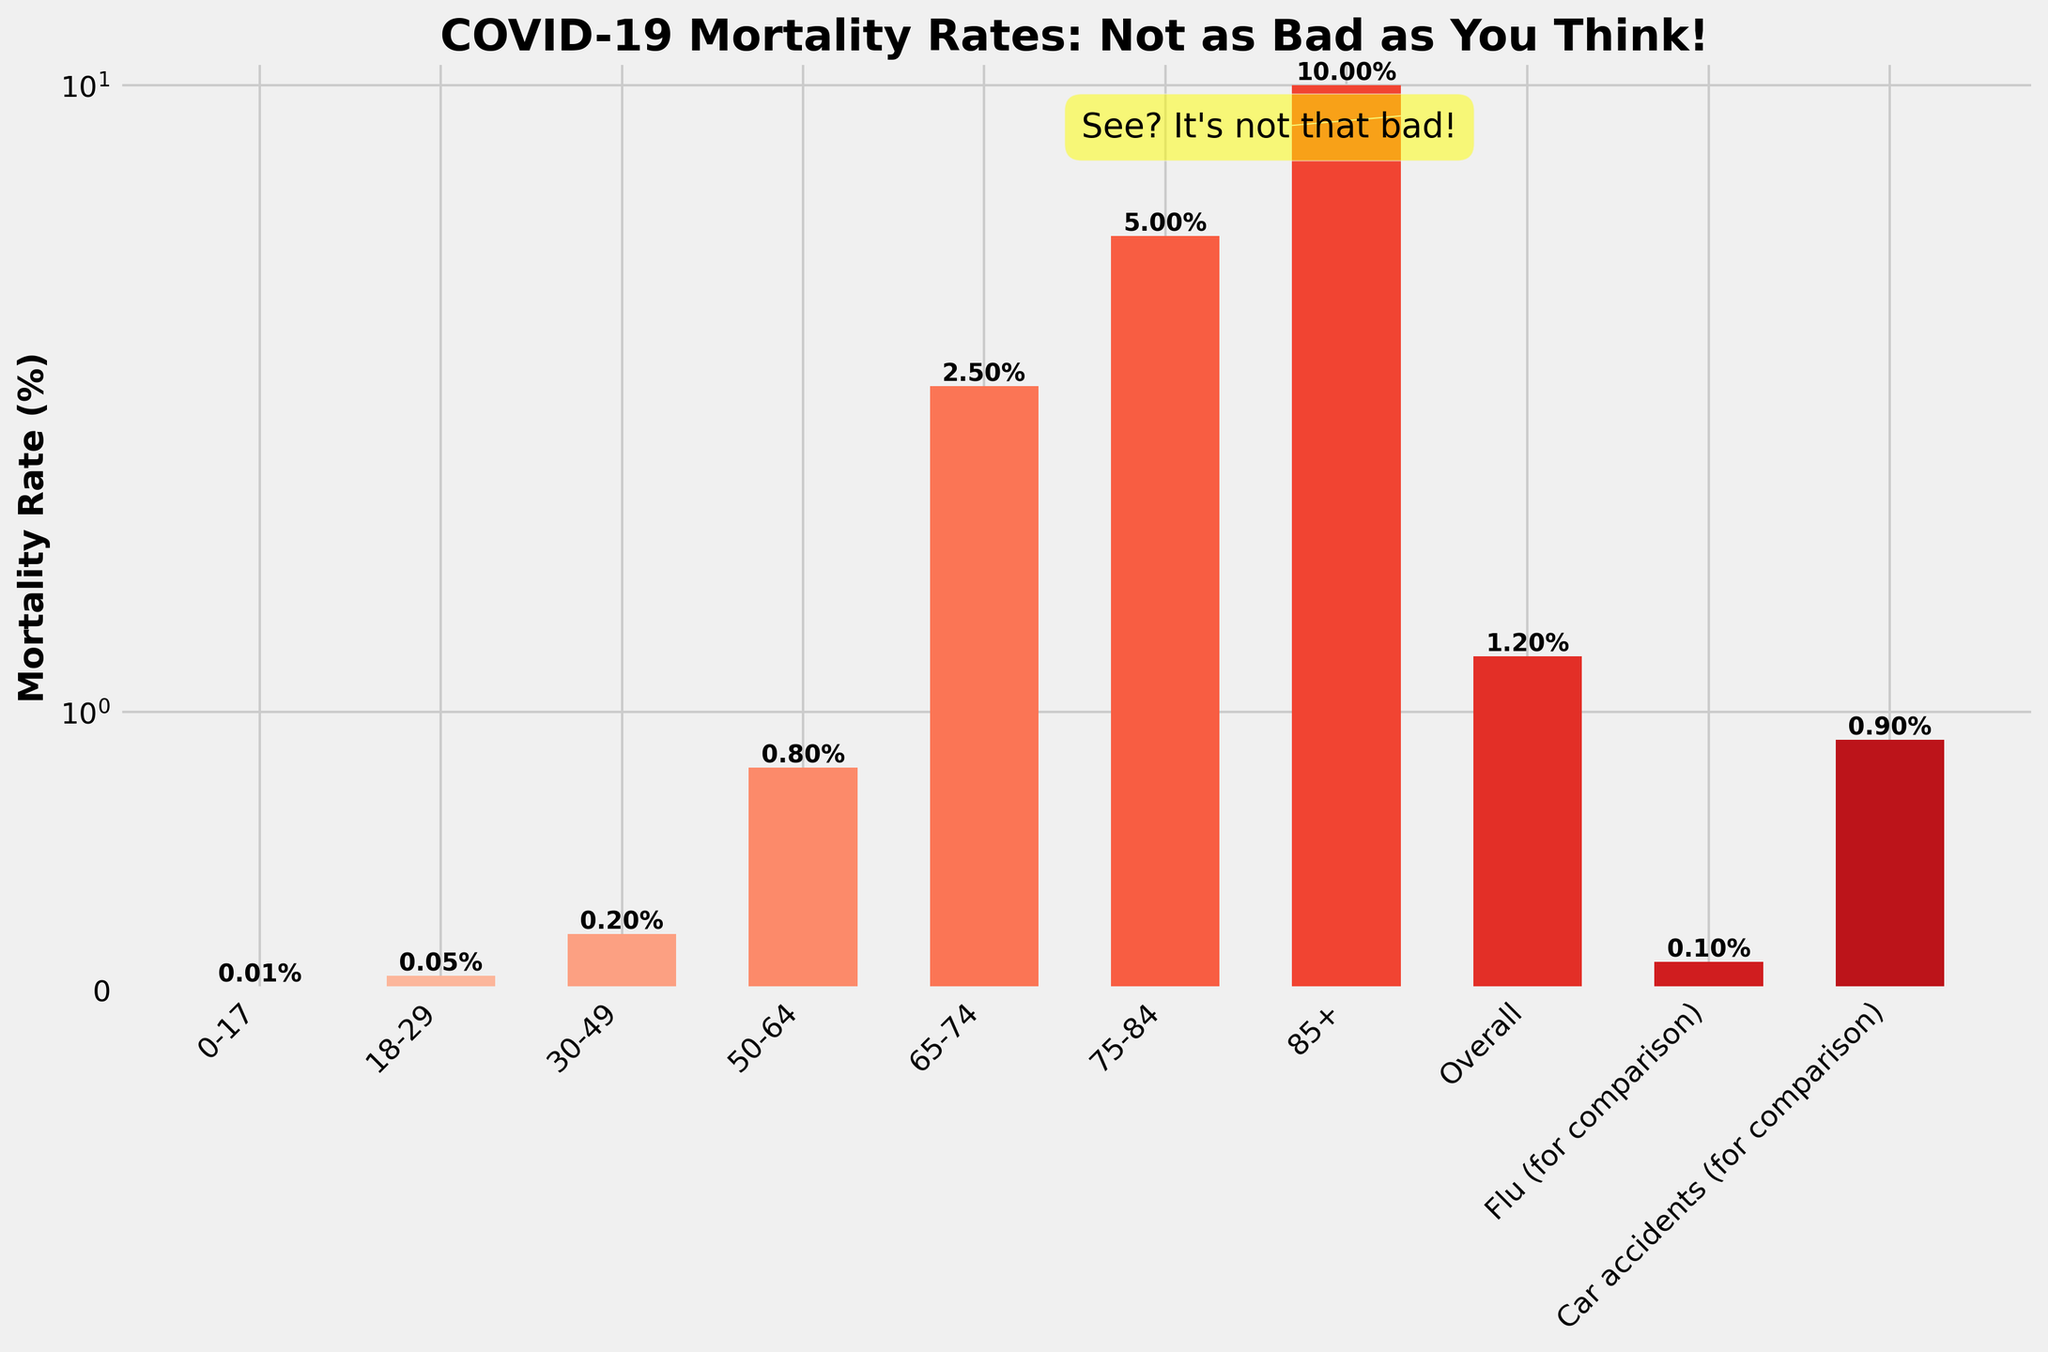Which age group has the highest COVID-19 mortality rate? The tallest bar on the right corresponds to the highest mortality rate, which is shown for the 85+ age group.
Answer: 85+ How does the COVID-19 mortality rate for those aged 50-64 compare to the mortality rate from car accidents? The height of the bar for the 50-64 age group is lower than the height of the bar representing car accidents.
Answer: Lower What is the difference in COVID-19 mortality rate between the 65-74 age group and the 75-84 age group? The bar for the 75-84 age group shows a rate of 5.0%, and the 65-74 age group shows a rate of 2.5%. The difference is 5.0% - 2.5%.
Answer: 2.5% Which category has the lowest COVID-19 mortality rate? The shortest bar corresponds to the 0-17 age group with a rate of 0.01%.
Answer: 0-17 Is there any age group that has a lower COVID-19 mortality rate than the overall rate of 1.2%? By comparing the heights of the bars, we can see that the 0-17, 18-29, and 30-49 age groups all have mortality rates lower than the overall rate.
Answer: Yes How does the COVID-19 mortality rate for ages 0-17 compare to the flu mortality rate? The bar for the 0-17 age group is shorter than the bar for the flu, indicating a lower mortality rate.
Answer: Lower Which age group has a COVID-19 mortality rate closest to 1%? The bar for the 50-64 age group shows a mortality rate of 0.8%, which is closest to 1%.
Answer: 50-64 What is the average COVID-19 mortality rate for the age groups 65-74, 75-84, and 85+? Add the mortality rates for 65-74 (2.5%), 75-84 (5.0%), and 85+ (10.0%) and divide by 3. (2.5 + 5.0 + 10.0) / 3 = 17.5 / 3
Answer: 5.83% Which age group sees an increase in COVID-19 mortality rate compared to the previous younger age group? Comparing the bars visually: 18-29 is higher than 0-17, 30-49 is higher than 18-29, 50-64 is higher than 30-49, 65-74 is higher than 50-64, 75-84 is higher than 65-74, and 85+ is higher than 75-84. Each group shows a higher rate than the preceding one.
Answer: Every subsequent age group 